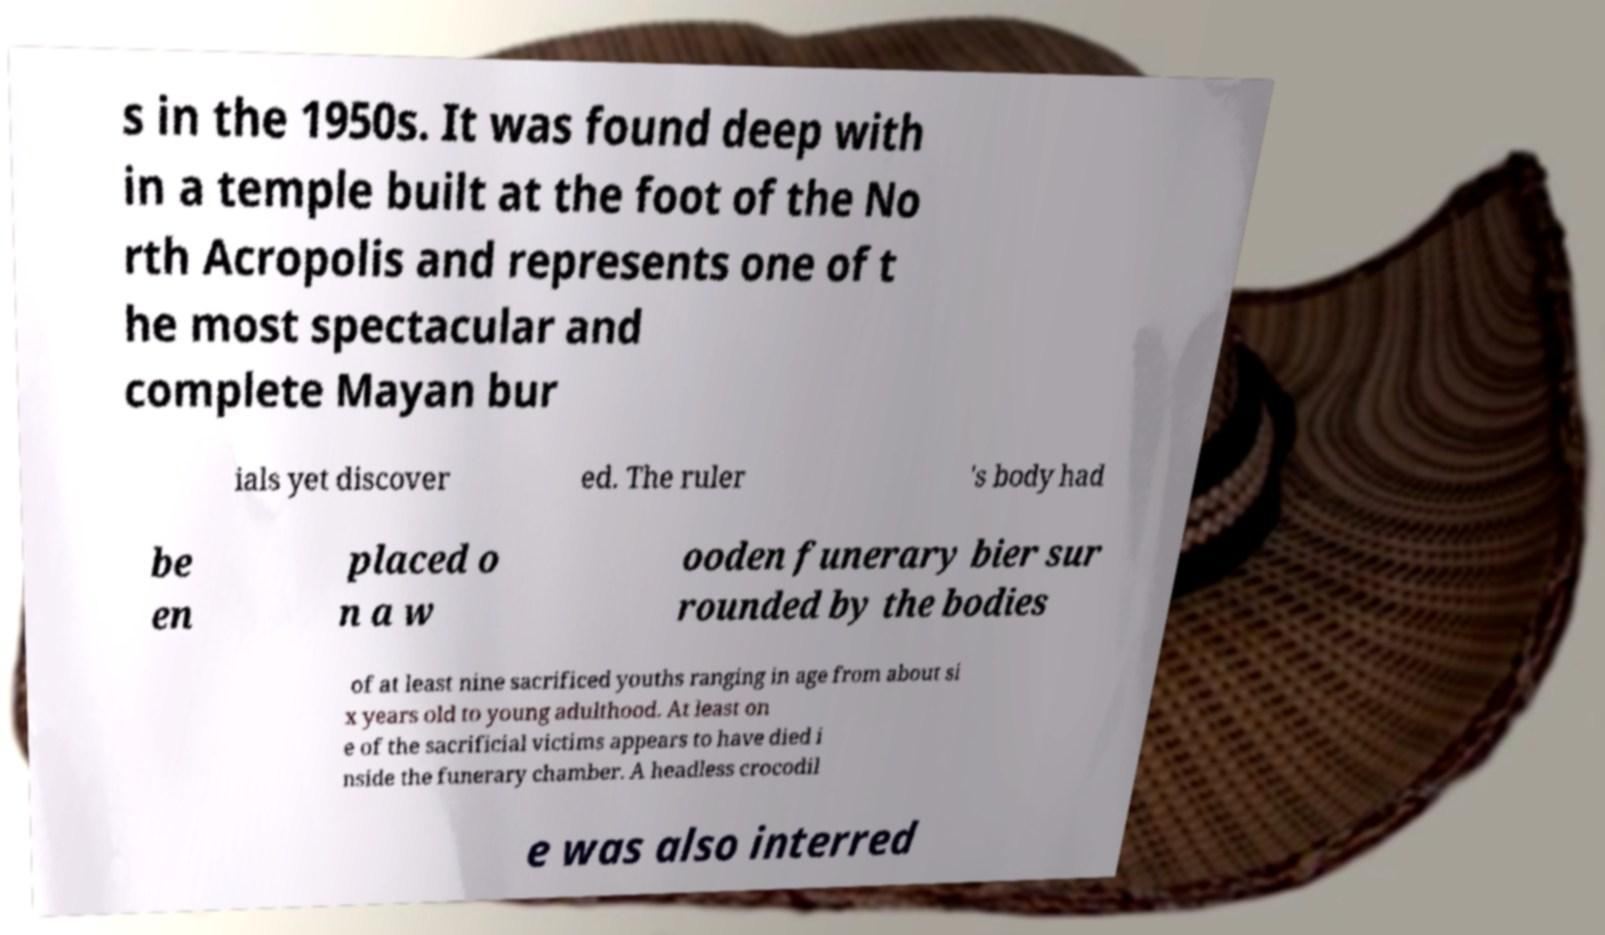What messages or text are displayed in this image? I need them in a readable, typed format. s in the 1950s. It was found deep with in a temple built at the foot of the No rth Acropolis and represents one of t he most spectacular and complete Mayan bur ials yet discover ed. The ruler 's body had be en placed o n a w ooden funerary bier sur rounded by the bodies of at least nine sacrificed youths ranging in age from about si x years old to young adulthood. At least on e of the sacrificial victims appears to have died i nside the funerary chamber. A headless crocodil e was also interred 